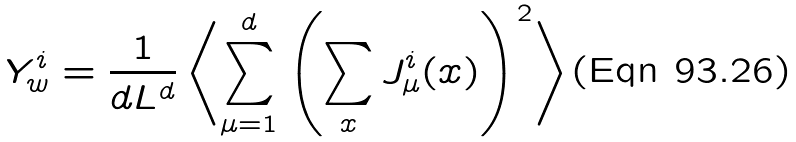Convert formula to latex. <formula><loc_0><loc_0><loc_500><loc_500>Y ^ { i } _ { w } = \frac { 1 } { d L ^ { d } } \left \langle \sum _ { \mu = 1 } ^ { d } \left ( \sum _ { x } J _ { \mu } ^ { i } ( x ) \right ) ^ { 2 } \right \rangle</formula> 